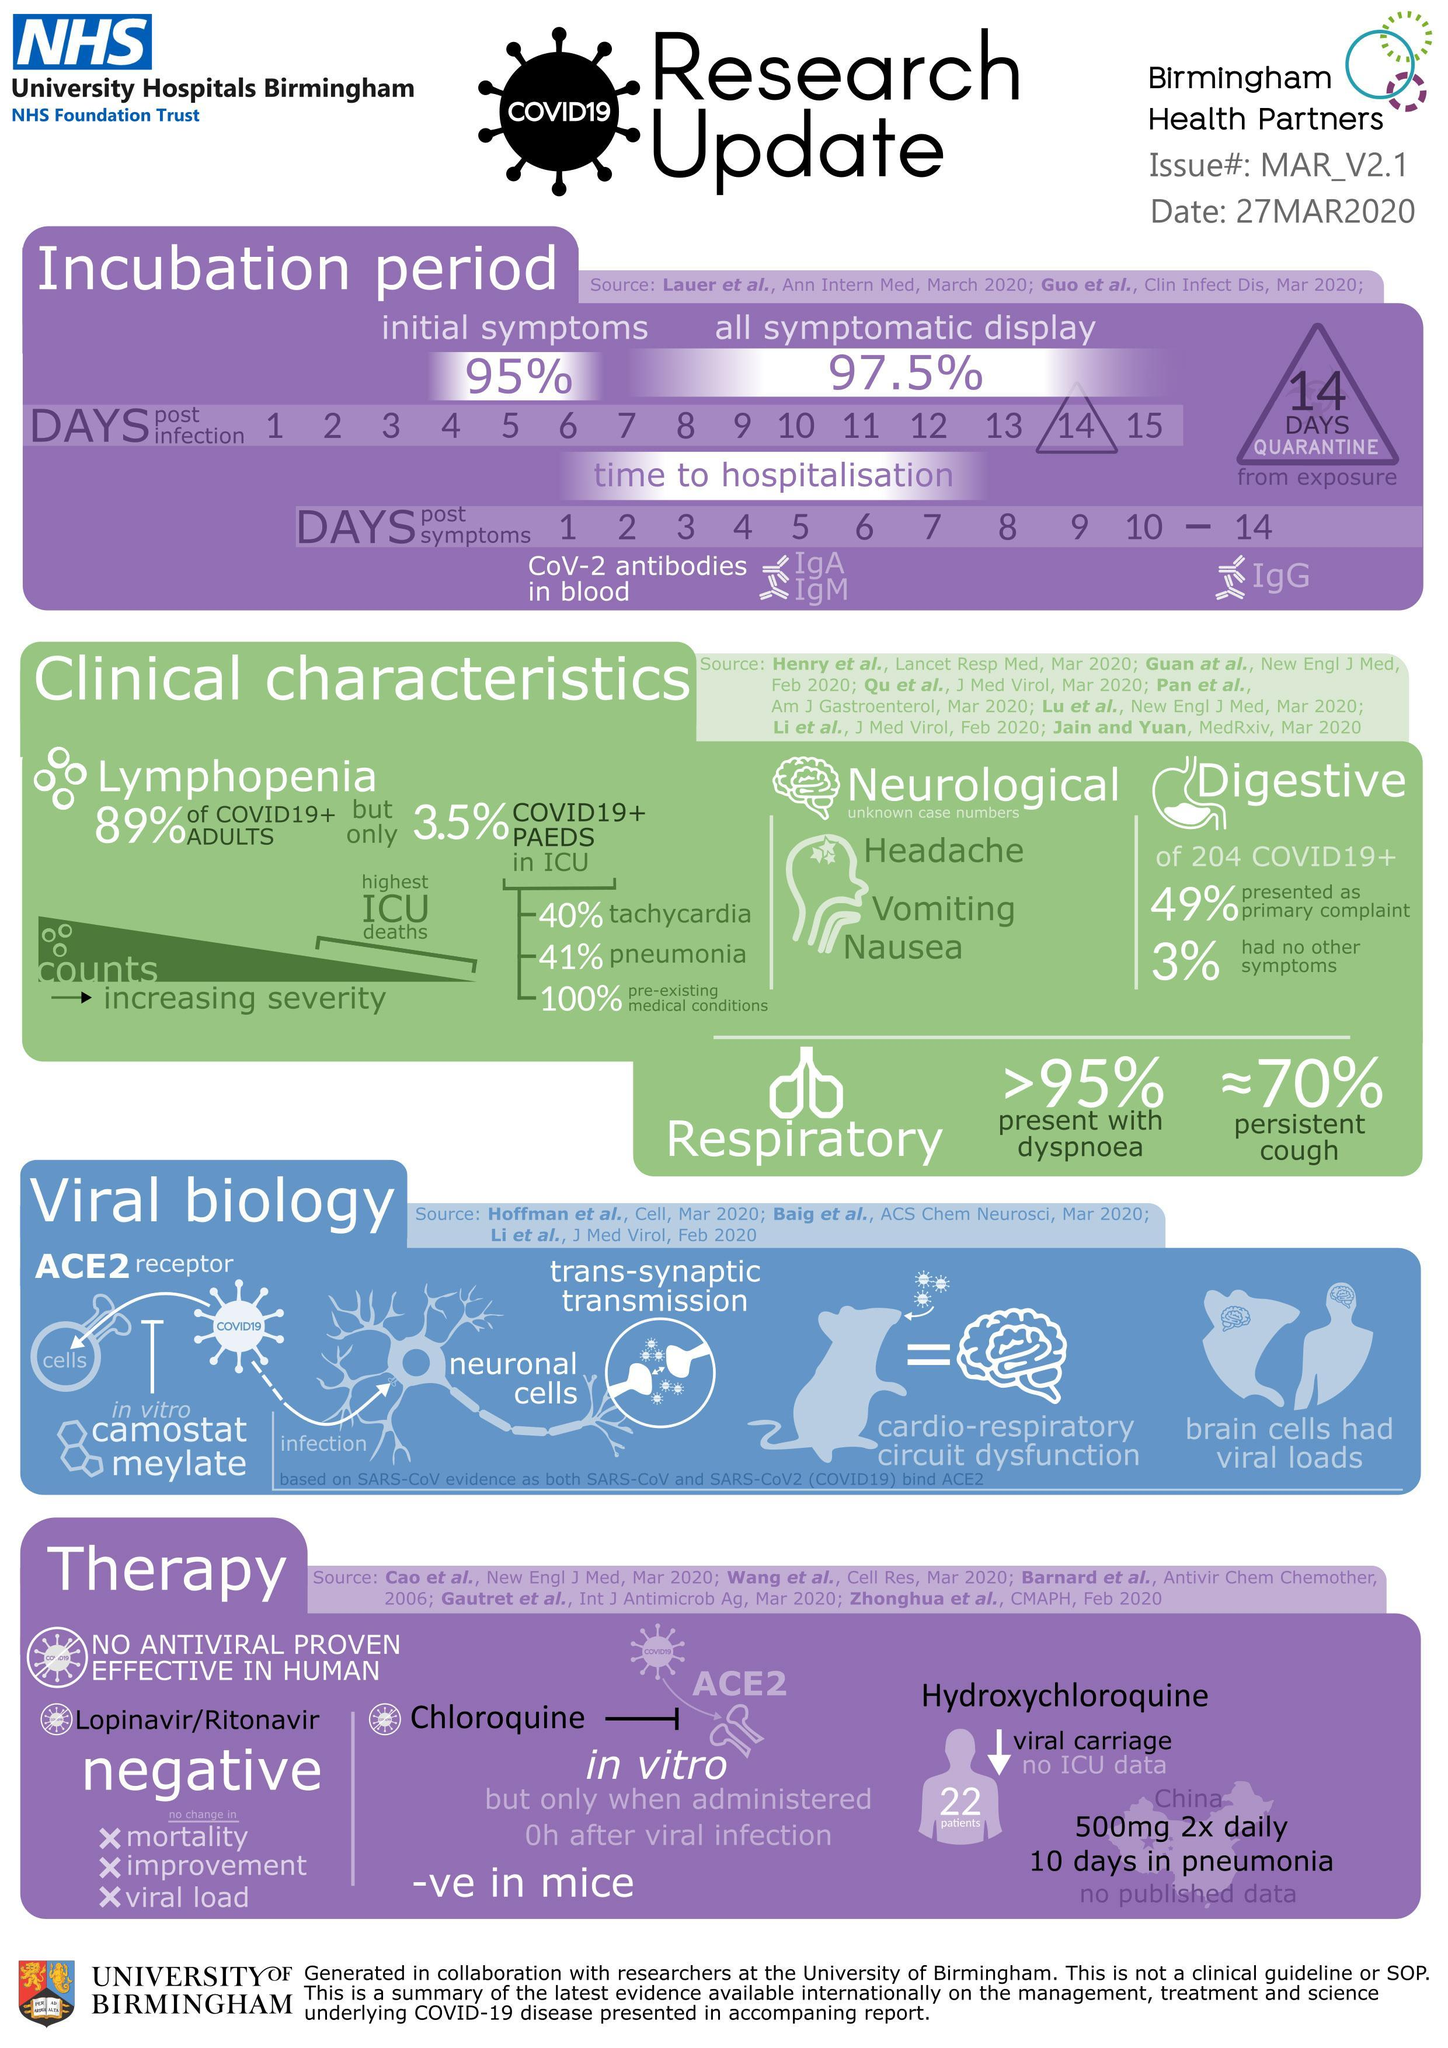What percentage of covid19+ cases have persistent cough?
Answer the question with a short phrase. 70% What percentage of 204 covid19+ cases had no other symptoms? 3% What percentage of 204 covid19+ cases have digestive problems as primary complaint? 49% What percentage of covid19+ cases are present with dyspnoea? >95% How many days of quarantine is mandatory after exposure to the Covid -19 virus? 14 days 